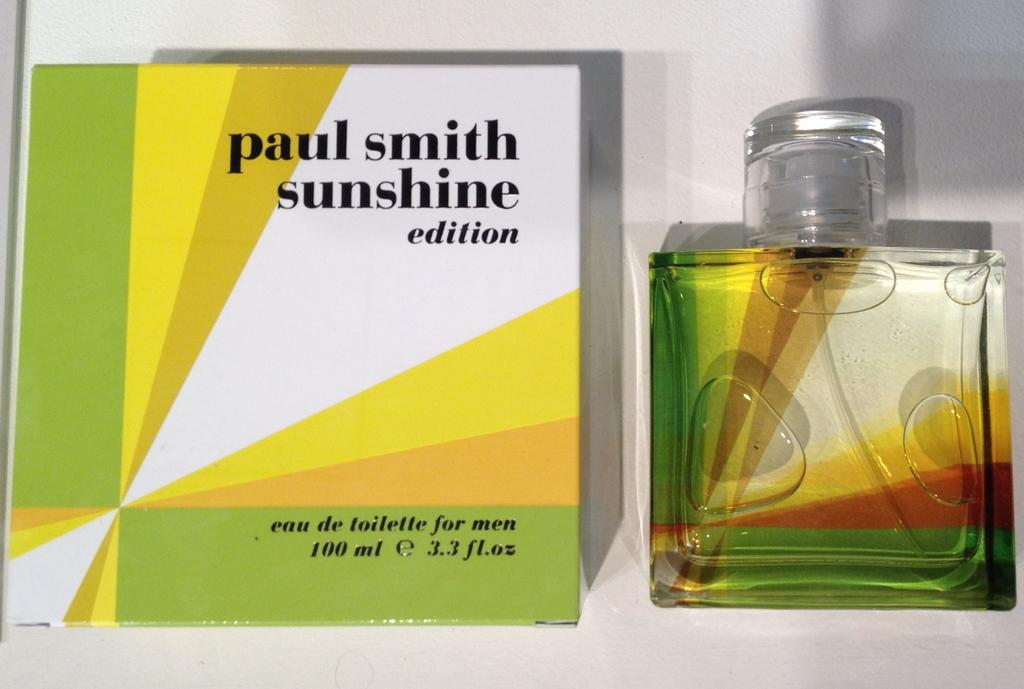Provide a one-sentence caption for the provided image. A bottle of Paul Smith Sunshine Edition is displayed next to its box. 